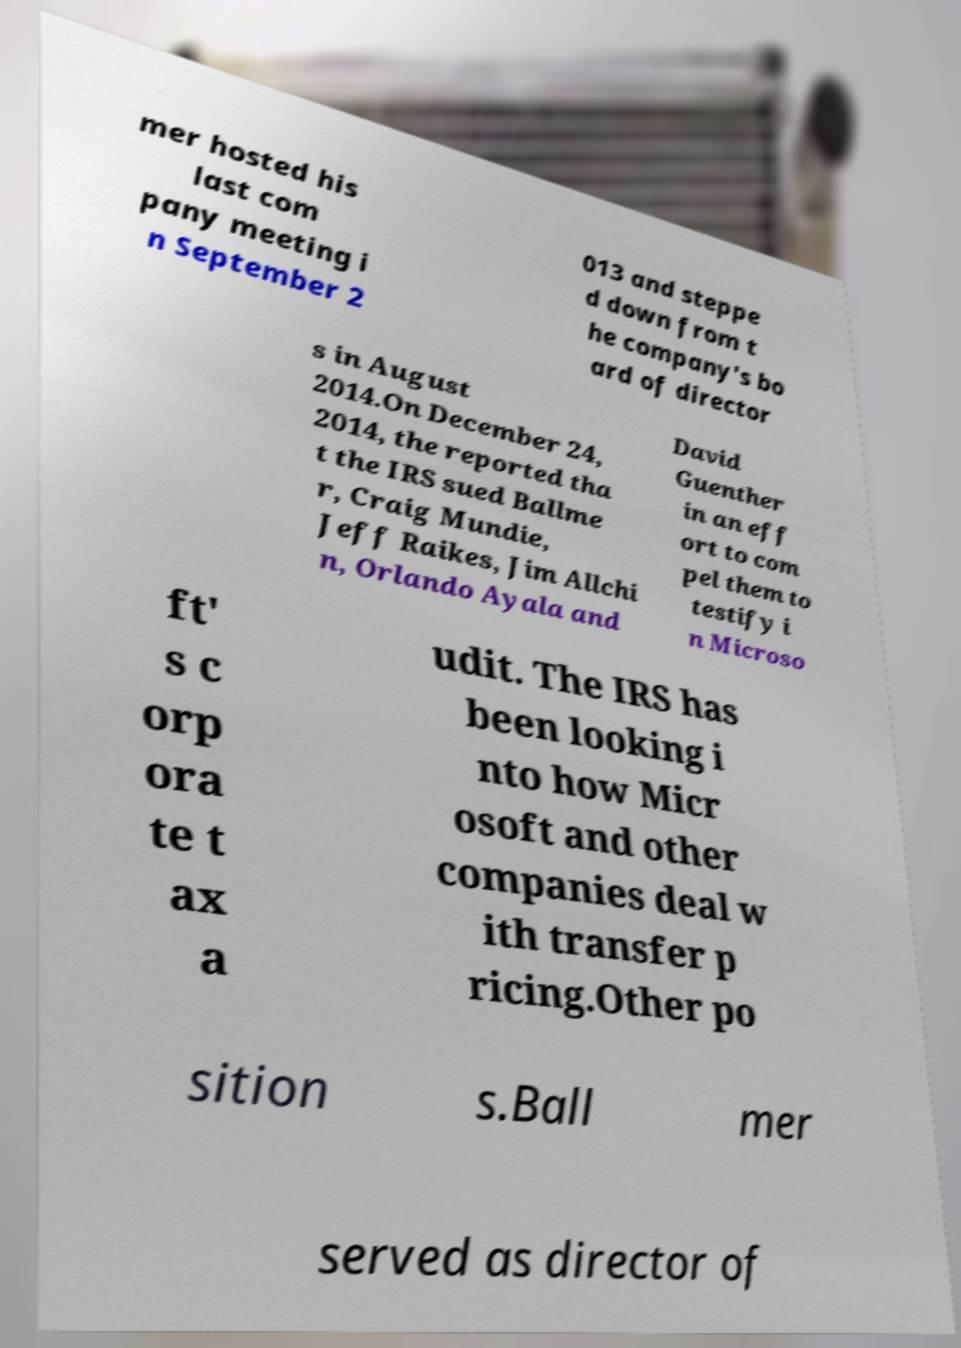For documentation purposes, I need the text within this image transcribed. Could you provide that? mer hosted his last com pany meeting i n September 2 013 and steppe d down from t he company's bo ard of director s in August 2014.On December 24, 2014, the reported tha t the IRS sued Ballme r, Craig Mundie, Jeff Raikes, Jim Allchi n, Orlando Ayala and David Guenther in an eff ort to com pel them to testify i n Microso ft' s c orp ora te t ax a udit. The IRS has been looking i nto how Micr osoft and other companies deal w ith transfer p ricing.Other po sition s.Ball mer served as director of 